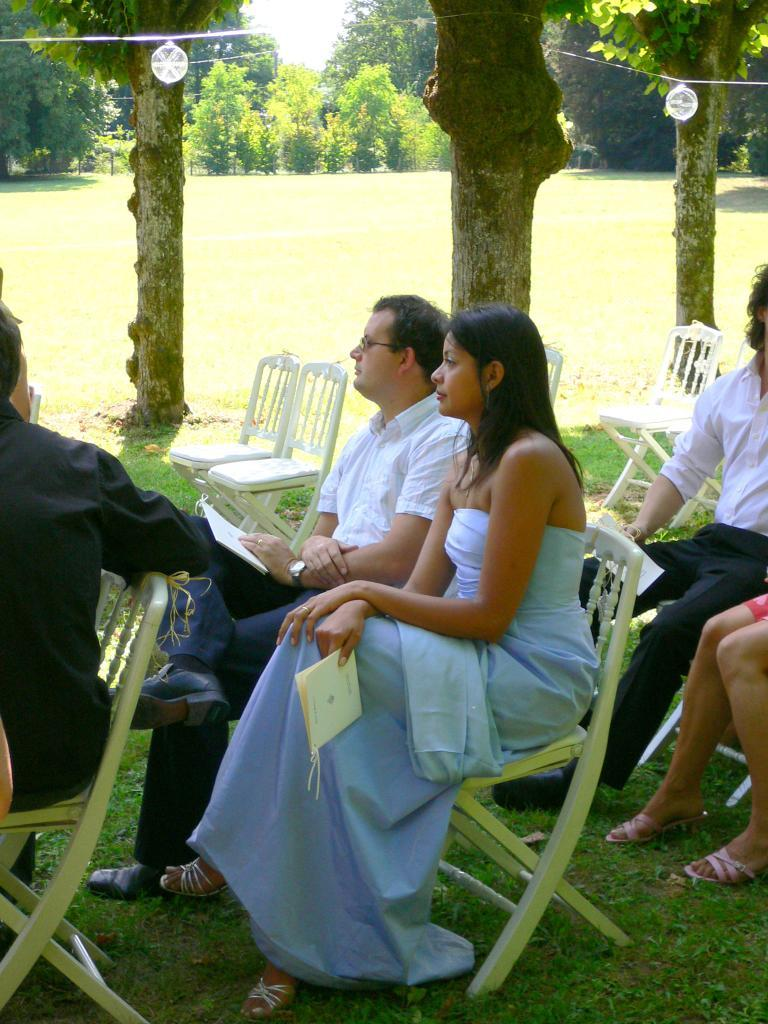How many people are present in the image? There are five persons in the image. What are the persons doing in the image? The persons are sitting on chairs. What can be seen in the background of the image? There are trees visible in the background of the image. What type of breakfast is being served in the image? There is no breakfast visible in the image; it only shows five persons sitting on chairs with trees in the background. 